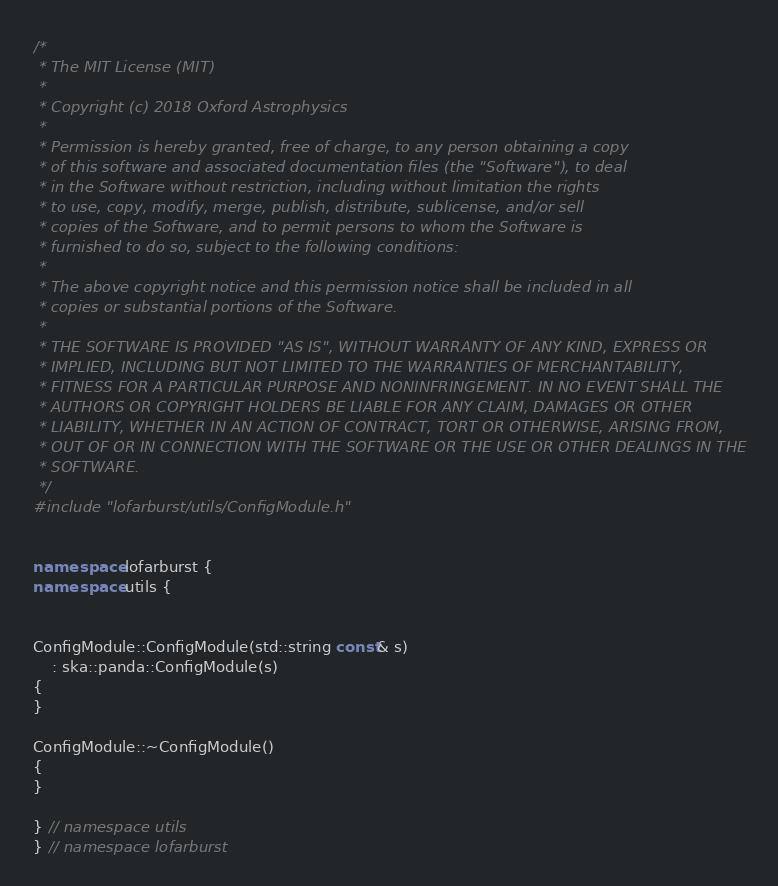<code> <loc_0><loc_0><loc_500><loc_500><_C++_>/*
 * The MIT License (MIT)
 * 
 * Copyright (c) 2018 Oxford Astrophysics
 * 
 * Permission is hereby granted, free of charge, to any person obtaining a copy
 * of this software and associated documentation files (the "Software"), to deal
 * in the Software without restriction, including without limitation the rights
 * to use, copy, modify, merge, publish, distribute, sublicense, and/or sell
 * copies of the Software, and to permit persons to whom the Software is
 * furnished to do so, subject to the following conditions:
 * 
 * The above copyright notice and this permission notice shall be included in all
 * copies or substantial portions of the Software.
 * 
 * THE SOFTWARE IS PROVIDED "AS IS", WITHOUT WARRANTY OF ANY KIND, EXPRESS OR
 * IMPLIED, INCLUDING BUT NOT LIMITED TO THE WARRANTIES OF MERCHANTABILITY,
 * FITNESS FOR A PARTICULAR PURPOSE AND NONINFRINGEMENT. IN NO EVENT SHALL THE
 * AUTHORS OR COPYRIGHT HOLDERS BE LIABLE FOR ANY CLAIM, DAMAGES OR OTHER
 * LIABILITY, WHETHER IN AN ACTION OF CONTRACT, TORT OR OTHERWISE, ARISING FROM,
 * OUT OF OR IN CONNECTION WITH THE SOFTWARE OR THE USE OR OTHER DEALINGS IN THE
 * SOFTWARE.
 */
#include "lofarburst/utils/ConfigModule.h"


namespace lofarburst {
namespace utils {


ConfigModule::ConfigModule(std::string const& s)
    : ska::panda::ConfigModule(s)
{
}

ConfigModule::~ConfigModule()
{
}

} // namespace utils
} // namespace lofarburst
</code> 